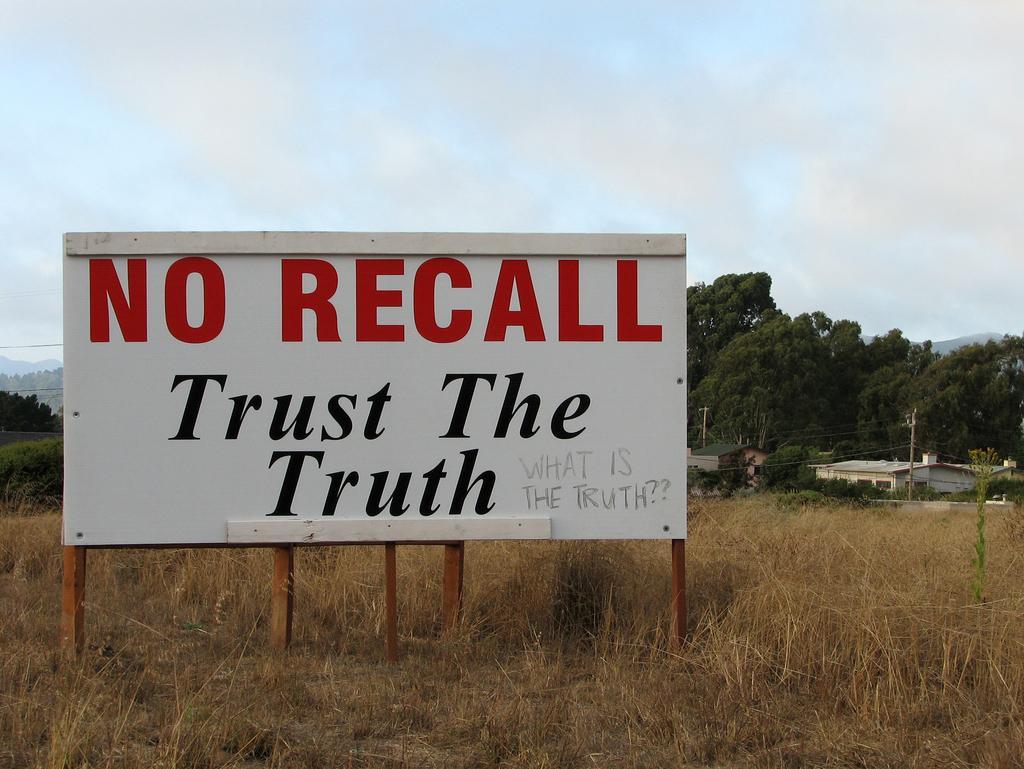How would you summarize this image in a sentence or two? In this picture I can observe white color board. I can observe some text on the board. There is some dried grass on the ground. In the background there are trees and some clouds in the sky. 